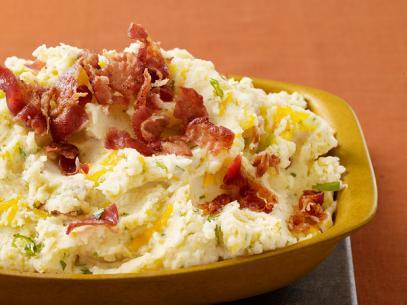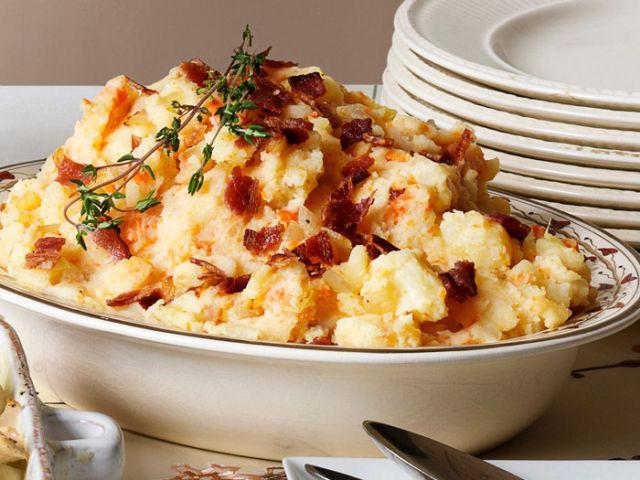The first image is the image on the left, the second image is the image on the right. For the images shown, is this caption "One image in the pair has more than one plate or bowl." true? Answer yes or no. Yes. 